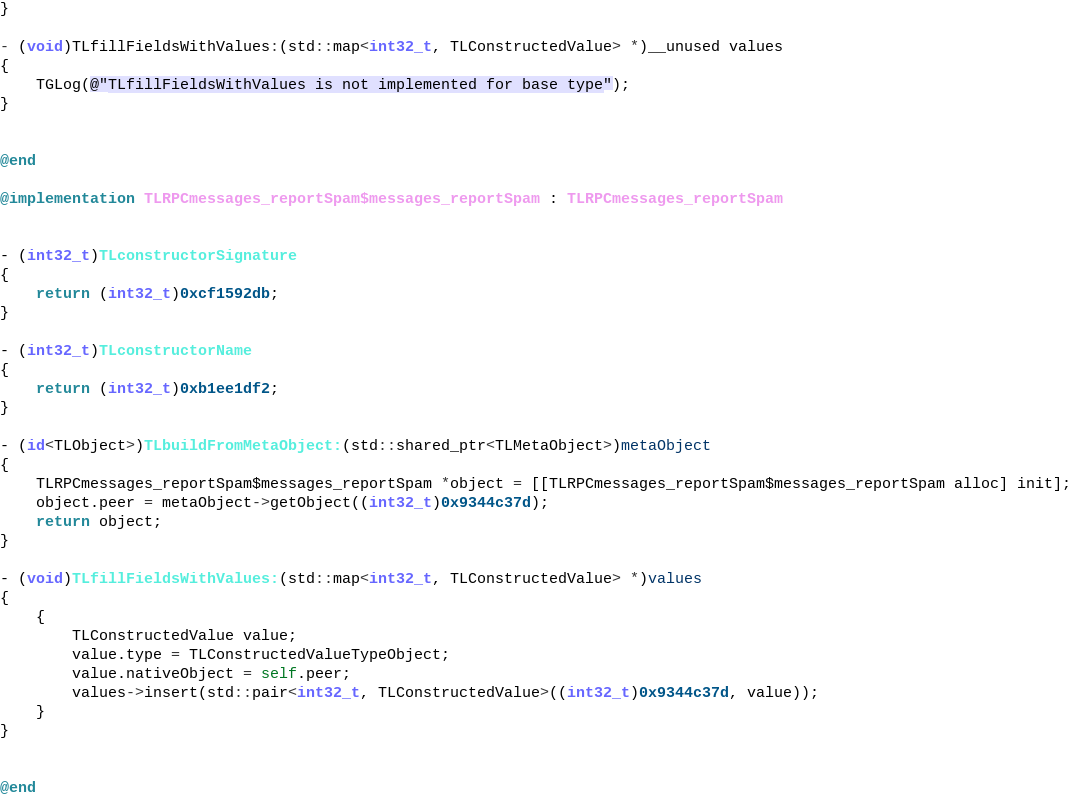<code> <loc_0><loc_0><loc_500><loc_500><_ObjectiveC_>}

- (void)TLfillFieldsWithValues:(std::map<int32_t, TLConstructedValue> *)__unused values
{
    TGLog(@"TLfillFieldsWithValues is not implemented for base type");
}


@end

@implementation TLRPCmessages_reportSpam$messages_reportSpam : TLRPCmessages_reportSpam


- (int32_t)TLconstructorSignature
{
    return (int32_t)0xcf1592db;
}

- (int32_t)TLconstructorName
{
    return (int32_t)0xb1ee1df2;
}

- (id<TLObject>)TLbuildFromMetaObject:(std::shared_ptr<TLMetaObject>)metaObject
{
    TLRPCmessages_reportSpam$messages_reportSpam *object = [[TLRPCmessages_reportSpam$messages_reportSpam alloc] init];
    object.peer = metaObject->getObject((int32_t)0x9344c37d);
    return object;
}

- (void)TLfillFieldsWithValues:(std::map<int32_t, TLConstructedValue> *)values
{
    {
        TLConstructedValue value;
        value.type = TLConstructedValueTypeObject;
        value.nativeObject = self.peer;
        values->insert(std::pair<int32_t, TLConstructedValue>((int32_t)0x9344c37d, value));
    }
}


@end

</code> 